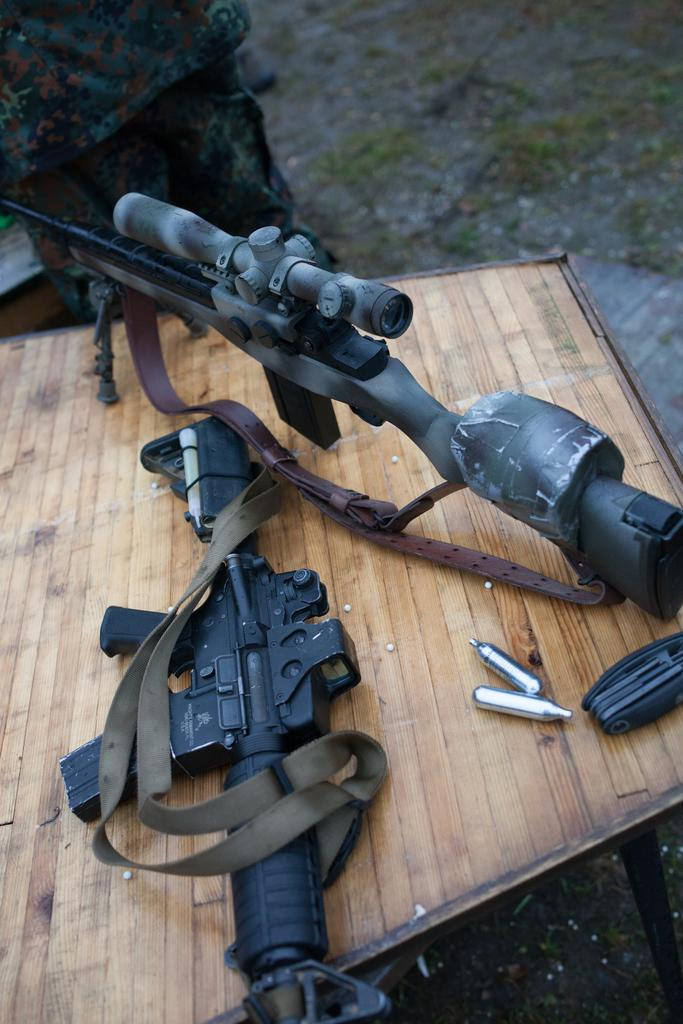What objects are present on the wooden table in the image? There are two guns on the wooden table in the image. Can you describe the appearance of one of the guns? One of the guns is black in color. What is the surface on which the guns are placed? The guns are placed on a wooden table. What can be seen in the background of the image? There is land visible in the background of the image. Are there any family members visible in the image? There is no mention of family members in the provided facts, so we cannot determine if any are present in the image. What type of insect can be seen crawling on the guns in the image? There is no insect present on the guns in the image, as the provided facts do not mention any insects. 